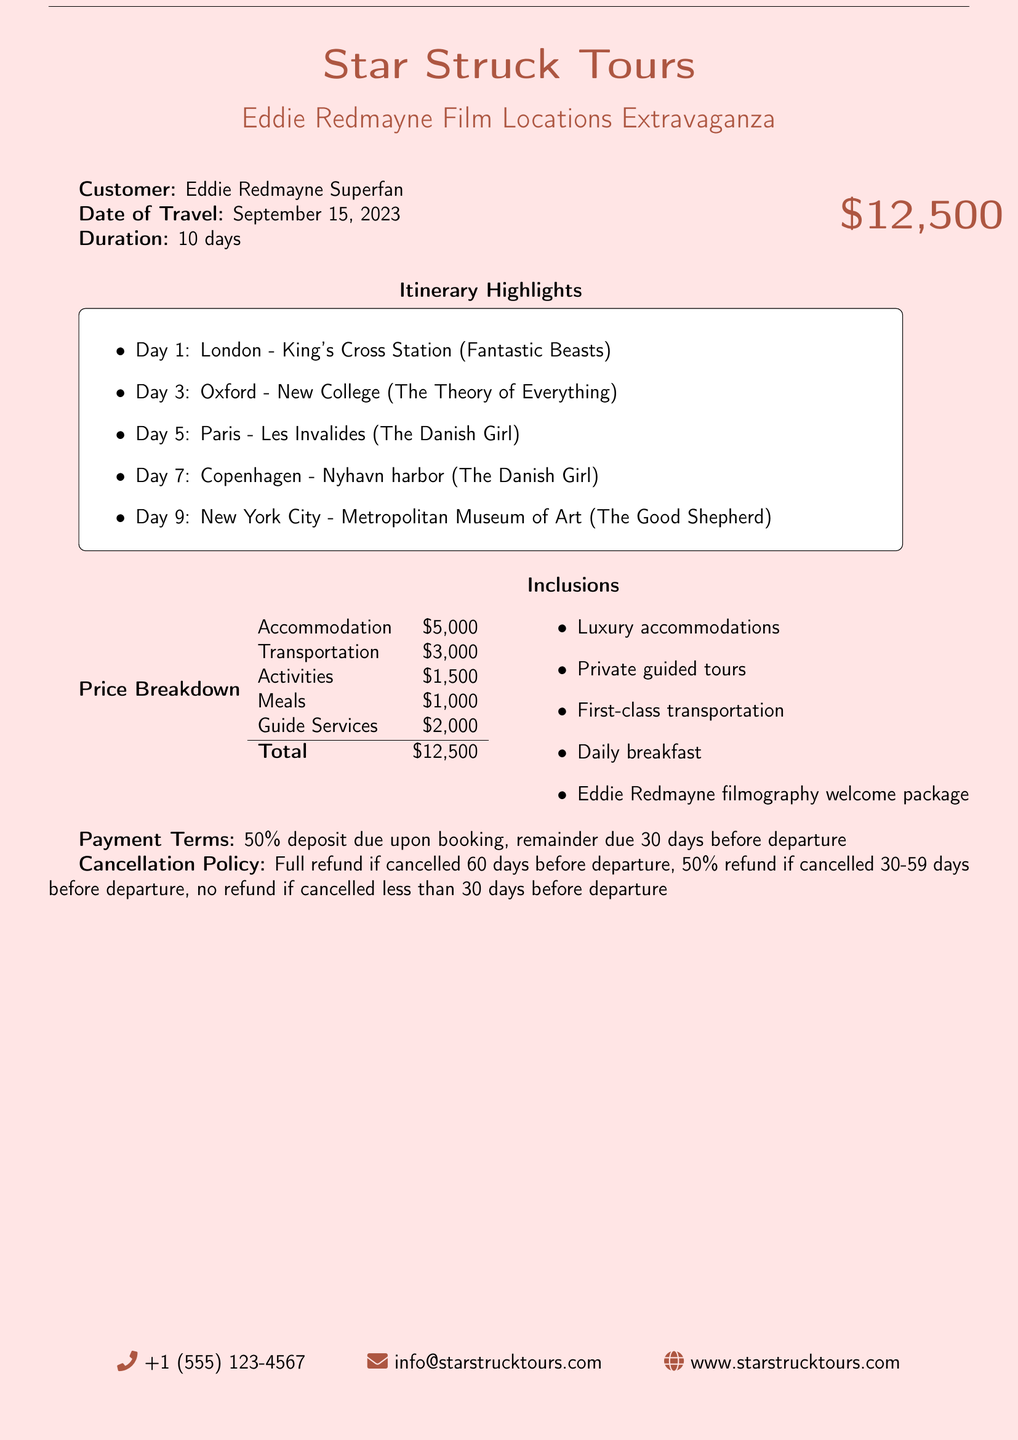What is the total cost of the tour package? The total cost is listed at the end of the price breakdown section of the document.
Answer: $12,500 What is the date of travel? The date of travel is noted in the customer details section.
Answer: September 15, 2023 How many days will the tour last? The duration of the tour is also mentioned in the customer details section.
Answer: 10 days What is included in the tour package? The inclusions section lists what is part of the tour, which can be found near the bottom of the document.
Answer: Luxury accommodations, Private guided tours, First-class transportation, Daily breakfast, Eddie Redmayne filmography welcome package What is the cancellation policy for the tour? The cancellation policy is outlined toward the end of the document, explaining the refund conditions.
Answer: Full refund if cancelled 60 days before departure, 50% refund if cancelled 30-59 days before departure, no refund if cancelled less than 30 days before departure How much is allocated for transportation? The price breakdown section provides a detailed allocation of the total cost, including transportation.
Answer: $3,000 What is the first location listed in the itinerary? The itinerary highlights section provides details of travel plans, including the first location.
Answer: London - King's Cross Station What kind of welcome package is included? The inclusions section mentions a specific type of welcome package as part of the tour.
Answer: Eddie Redmayne filmography welcome package What is the phone number for Star Struck Tours? The contact information at the bottom of the document includes the phone number.
Answer: +1 (555) 123-4567 